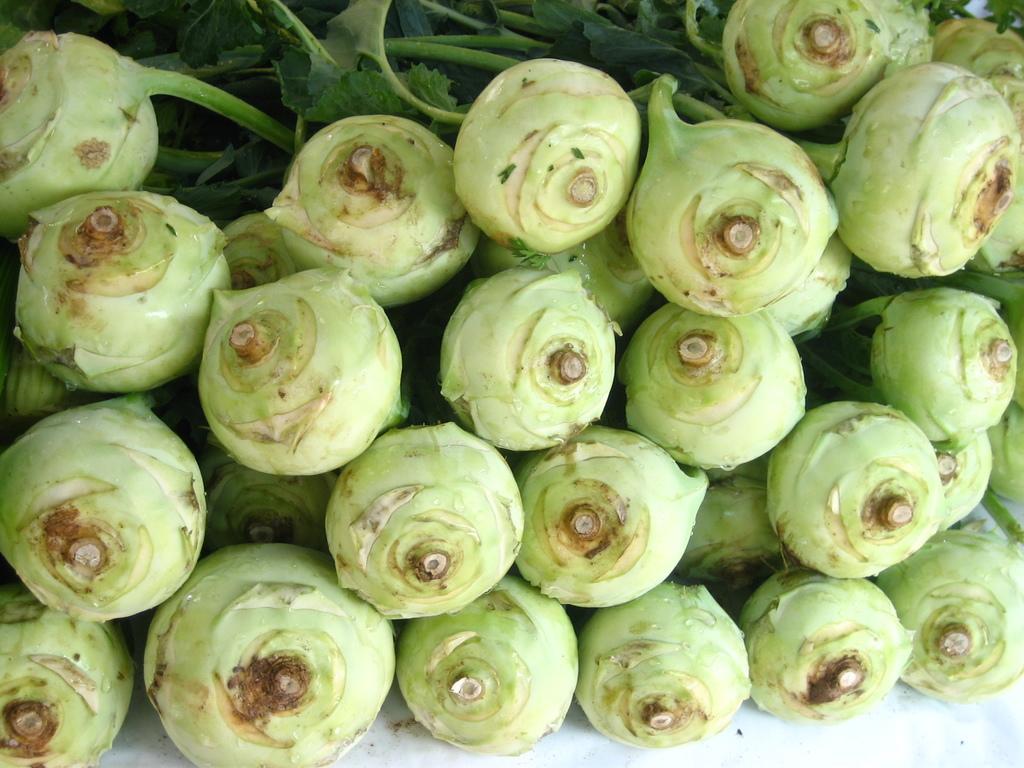How would you summarize this image in a sentence or two? In this image we can see vegetables on the white color surface. 